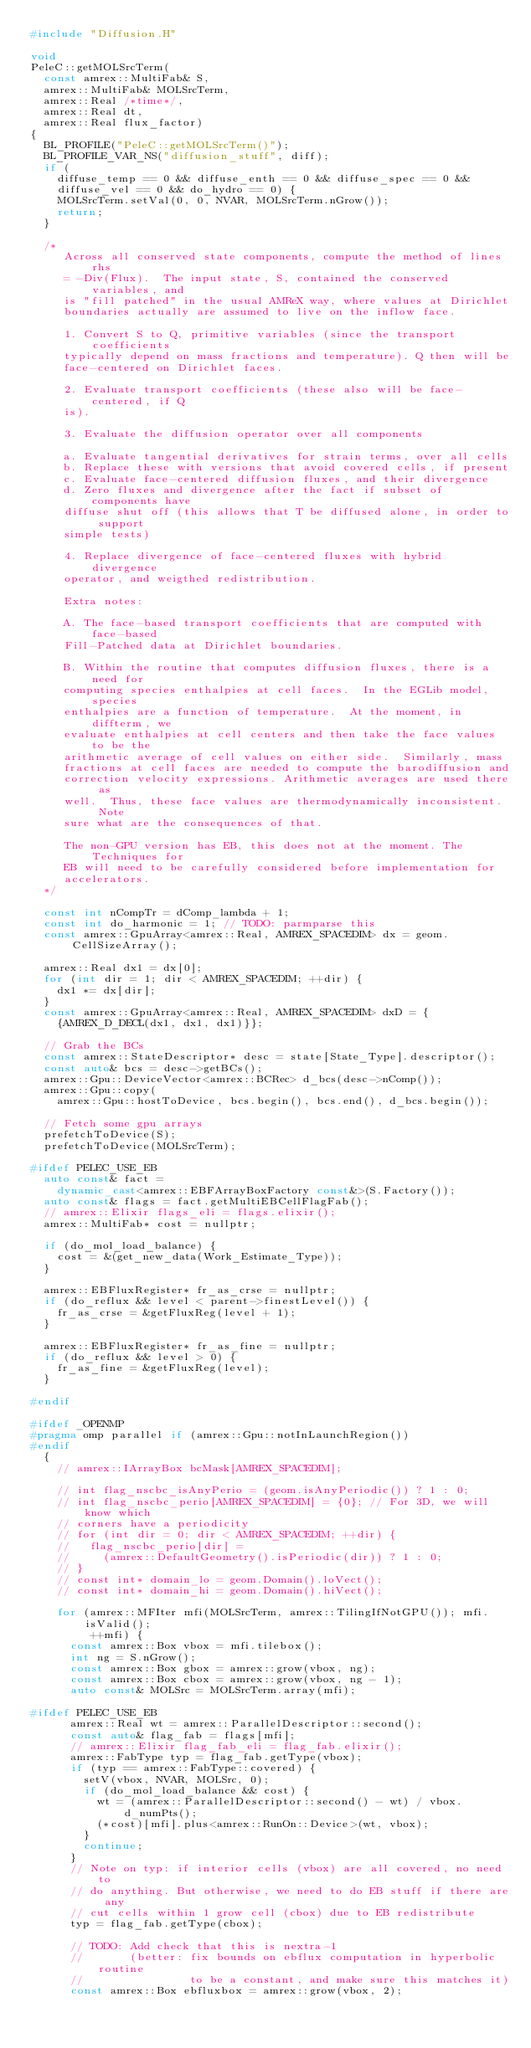<code> <loc_0><loc_0><loc_500><loc_500><_C++_>#include "Diffusion.H"

void
PeleC::getMOLSrcTerm(
  const amrex::MultiFab& S,
  amrex::MultiFab& MOLSrcTerm,
  amrex::Real /*time*/,
  amrex::Real dt,
  amrex::Real flux_factor)
{
  BL_PROFILE("PeleC::getMOLSrcTerm()");
  BL_PROFILE_VAR_NS("diffusion_stuff", diff);
  if (
    diffuse_temp == 0 && diffuse_enth == 0 && diffuse_spec == 0 &&
    diffuse_vel == 0 && do_hydro == 0) {
    MOLSrcTerm.setVal(0, 0, NVAR, MOLSrcTerm.nGrow());
    return;
  }

  /*
     Across all conserved state components, compute the method of lines rhs
     = -Div(Flux).  The input state, S, contained the conserved variables, and
     is "fill patched" in the usual AMReX way, where values at Dirichlet
     boundaries actually are assumed to live on the inflow face.

     1. Convert S to Q, primitive variables (since the transport coefficients
     typically depend on mass fractions and temperature). Q then will be
     face-centered on Dirichlet faces.

     2. Evaluate transport coefficients (these also will be face-centered, if Q
     is).

     3. Evaluate the diffusion operator over all components

     a. Evaluate tangential derivatives for strain terms, over all cells
     b. Replace these with versions that avoid covered cells, if present
     c. Evaluate face-centered diffusion fluxes, and their divergence
     d. Zero fluxes and divergence after the fact if subset of components have
     diffuse shut off (this allows that T be diffused alone, in order to support
     simple tests)

     4. Replace divergence of face-centered fluxes with hybrid divergence
     operator, and weigthed redistribution.

     Extra notes:

     A. The face-based transport coefficients that are computed with face-based
     Fill-Patched data at Dirichlet boundaries.

     B. Within the routine that computes diffusion fluxes, there is a need for
     computing species enthalpies at cell faces.  In the EGLib model, species
     enthalpies are a function of temperature.  At the moment, in diffterm, we
     evaluate enthalpies at cell centers and then take the face values to be the
     arithmetic average of cell values on either side.  Similarly, mass
     fractions at cell faces are needed to compute the barodiffusion and
     correction velocity expressions. Arithmetic averages are used there as
     well.  Thus, these face values are thermodynamically inconsistent.  Note
     sure what are the consequences of that.

     The non-GPU version has EB, this does not at the moment. The Techniques for
     EB will need to be carefully considered before implementation for
     accelerators.
  */

  const int nCompTr = dComp_lambda + 1;
  const int do_harmonic = 1; // TODO: parmparse this
  const amrex::GpuArray<amrex::Real, AMREX_SPACEDIM> dx = geom.CellSizeArray();

  amrex::Real dx1 = dx[0];
  for (int dir = 1; dir < AMREX_SPACEDIM; ++dir) {
    dx1 *= dx[dir];
  }
  const amrex::GpuArray<amrex::Real, AMREX_SPACEDIM> dxD = {
    {AMREX_D_DECL(dx1, dx1, dx1)}};

  // Grab the BCs
  const amrex::StateDescriptor* desc = state[State_Type].descriptor();
  const auto& bcs = desc->getBCs();
  amrex::Gpu::DeviceVector<amrex::BCRec> d_bcs(desc->nComp());
  amrex::Gpu::copy(
    amrex::Gpu::hostToDevice, bcs.begin(), bcs.end(), d_bcs.begin());

  // Fetch some gpu arrays
  prefetchToDevice(S);
  prefetchToDevice(MOLSrcTerm);

#ifdef PELEC_USE_EB
  auto const& fact =
    dynamic_cast<amrex::EBFArrayBoxFactory const&>(S.Factory());
  auto const& flags = fact.getMultiEBCellFlagFab();
  // amrex::Elixir flags_eli = flags.elixir();
  amrex::MultiFab* cost = nullptr;

  if (do_mol_load_balance) {
    cost = &(get_new_data(Work_Estimate_Type));
  }

  amrex::EBFluxRegister* fr_as_crse = nullptr;
  if (do_reflux && level < parent->finestLevel()) {
    fr_as_crse = &getFluxReg(level + 1);
  }

  amrex::EBFluxRegister* fr_as_fine = nullptr;
  if (do_reflux && level > 0) {
    fr_as_fine = &getFluxReg(level);
  }

#endif

#ifdef _OPENMP
#pragma omp parallel if (amrex::Gpu::notInLaunchRegion())
#endif
  {
    // amrex::IArrayBox bcMask[AMREX_SPACEDIM];

    // int flag_nscbc_isAnyPerio = (geom.isAnyPeriodic()) ? 1 : 0;
    // int flag_nscbc_perio[AMREX_SPACEDIM] = {0}; // For 3D, we will know which
    // corners have a periodicity
    // for (int dir = 0; dir < AMREX_SPACEDIM; ++dir) {
    //   flag_nscbc_perio[dir] =
    //     (amrex::DefaultGeometry().isPeriodic(dir)) ? 1 : 0;
    // }
    // const int* domain_lo = geom.Domain().loVect();
    // const int* domain_hi = geom.Domain().hiVect();

    for (amrex::MFIter mfi(MOLSrcTerm, amrex::TilingIfNotGPU()); mfi.isValid();
         ++mfi) {
      const amrex::Box vbox = mfi.tilebox();
      int ng = S.nGrow();
      const amrex::Box gbox = amrex::grow(vbox, ng);
      const amrex::Box cbox = amrex::grow(vbox, ng - 1);
      auto const& MOLSrc = MOLSrcTerm.array(mfi);

#ifdef PELEC_USE_EB
      amrex::Real wt = amrex::ParallelDescriptor::second();
      const auto& flag_fab = flags[mfi];
      // amrex::Elixir flag_fab_eli = flag_fab.elixir();
      amrex::FabType typ = flag_fab.getType(vbox);
      if (typ == amrex::FabType::covered) {
        setV(vbox, NVAR, MOLSrc, 0);
        if (do_mol_load_balance && cost) {
          wt = (amrex::ParallelDescriptor::second() - wt) / vbox.d_numPts();
          (*cost)[mfi].plus<amrex::RunOn::Device>(wt, vbox);
        }
        continue;
      }
      // Note on typ: if interior cells (vbox) are all covered, no need to
      // do anything. But otherwise, we need to do EB stuff if there are any
      // cut cells within 1 grow cell (cbox) due to EB redistribute
      typ = flag_fab.getType(cbox);

      // TODO: Add check that this is nextra-1
      //       (better: fix bounds on ebflux computation in hyperbolic routine
      //                to be a constant, and make sure this matches it)
      const amrex::Box ebfluxbox = amrex::grow(vbox, 2);
</code> 